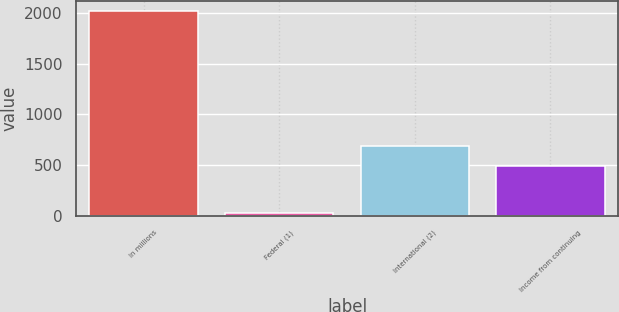<chart> <loc_0><loc_0><loc_500><loc_500><bar_chart><fcel>In millions<fcel>Federal (1)<fcel>International (2)<fcel>Income from continuing<nl><fcel>2017<fcel>32.8<fcel>687.62<fcel>489.2<nl></chart> 